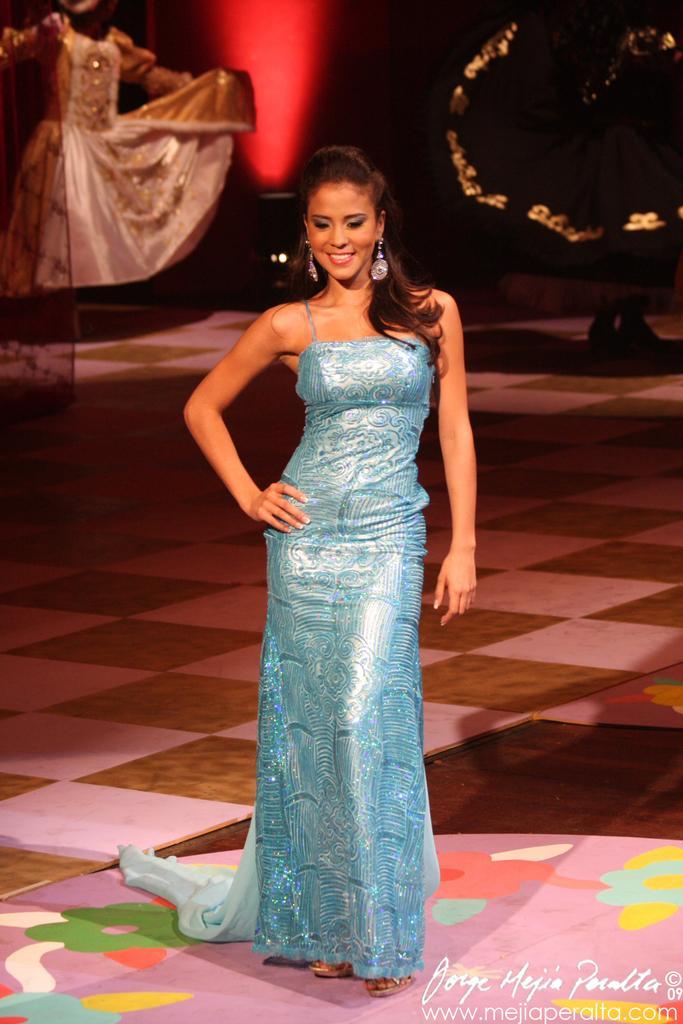Please provide a concise description of this image. In the middle of the image a woman is standing and smiling. Behind her two persons are standing. 